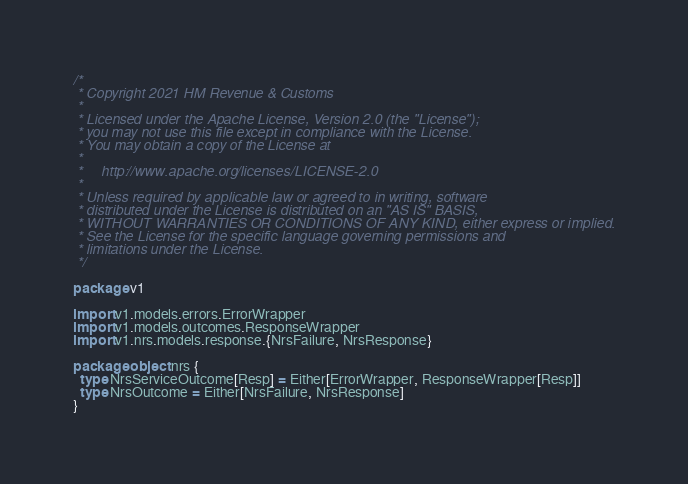<code> <loc_0><loc_0><loc_500><loc_500><_Scala_>/*
 * Copyright 2021 HM Revenue & Customs
 *
 * Licensed under the Apache License, Version 2.0 (the "License");
 * you may not use this file except in compliance with the License.
 * You may obtain a copy of the License at
 *
 *     http://www.apache.org/licenses/LICENSE-2.0
 *
 * Unless required by applicable law or agreed to in writing, software
 * distributed under the License is distributed on an "AS IS" BASIS,
 * WITHOUT WARRANTIES OR CONDITIONS OF ANY KIND, either express or implied.
 * See the License for the specific language governing permissions and
 * limitations under the License.
 */

package v1

import v1.models.errors.ErrorWrapper
import v1.models.outcomes.ResponseWrapper
import v1.nrs.models.response.{NrsFailure, NrsResponse}

package object nrs {
  type NrsServiceOutcome[Resp] = Either[ErrorWrapper, ResponseWrapper[Resp]]
  type NrsOutcome = Either[NrsFailure, NrsResponse]
}
</code> 